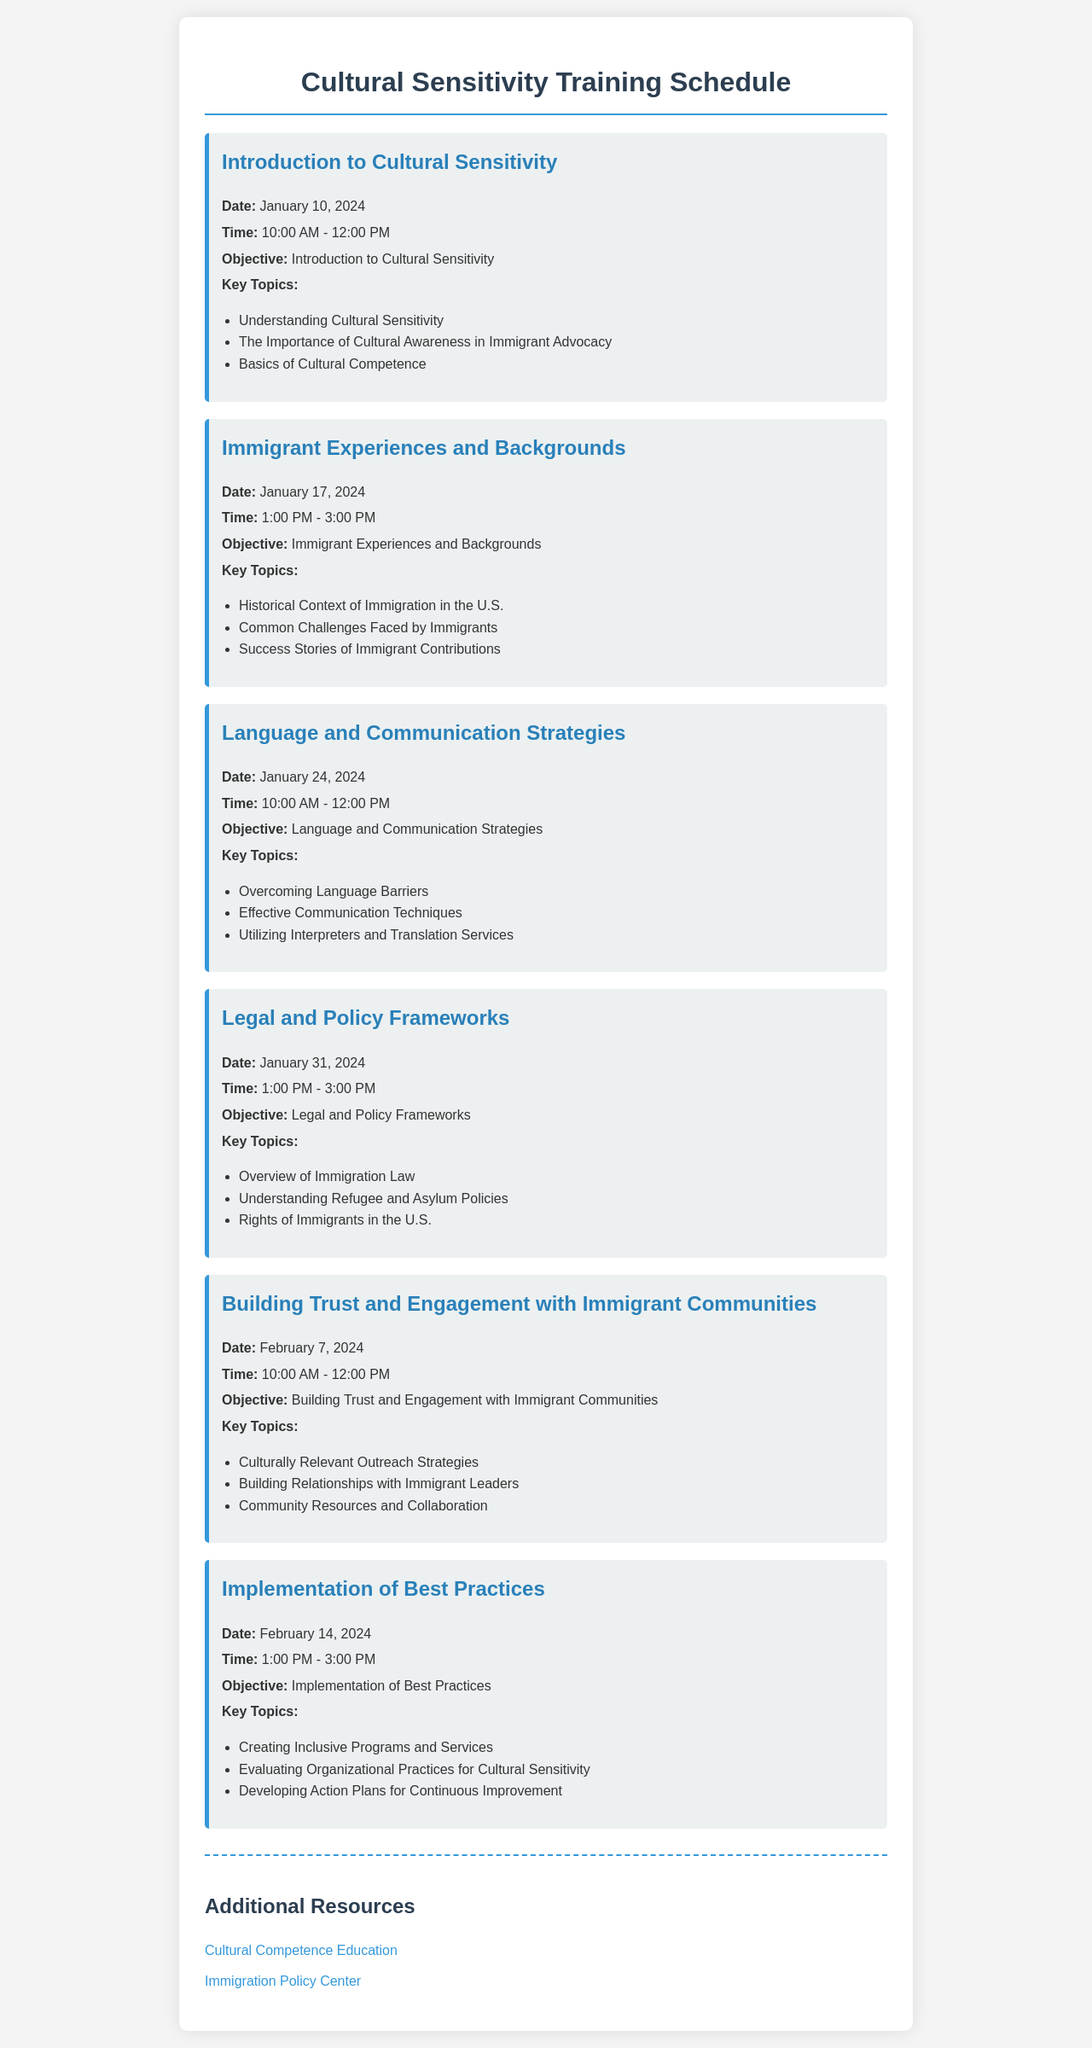What is the first training session title? The document lists the first training session as "Introduction to Cultural Sensitivity."
Answer: Introduction to Cultural Sensitivity What is the date of the session on Immigrant Experiences and Backgrounds? The session on Immigrant Experiences and Backgrounds is scheduled for January 17, 2024.
Answer: January 17, 2024 What is the time slot for the Language and Communication Strategies session? The Language and Communication Strategies session is from 10:00 AM to 12:00 PM.
Answer: 10:00 AM - 12:00 PM How many sessions are scheduled in February 2024? There are two training sessions scheduled in February 2024.
Answer: Two What are the key topics covered in the session about Legal and Policy Frameworks? The session covers Immigration Law, Refugee and Asylum Policies, and Rights of Immigrants.
Answer: Overview of Immigration Law, Understanding Refugee and Asylum Policies, Rights of Immigrants in the U.S What is the objective of the last session? The last session aims to teach about "Implementation of Best Practices."
Answer: Implementation of Best Practices Which session focuses on engaging with immigrant communities? The session titled "Building Trust and Engagement with Immigrant Communities" focuses on this topic.
Answer: Building Trust and Engagement with Immigrant Communities What type of additional resources are provided at the end of the document? The document provides links to Cultural Competence Education and Immigration Policy Center.
Answer: Links to Cultural Competence Education and Immigration Policy Center 